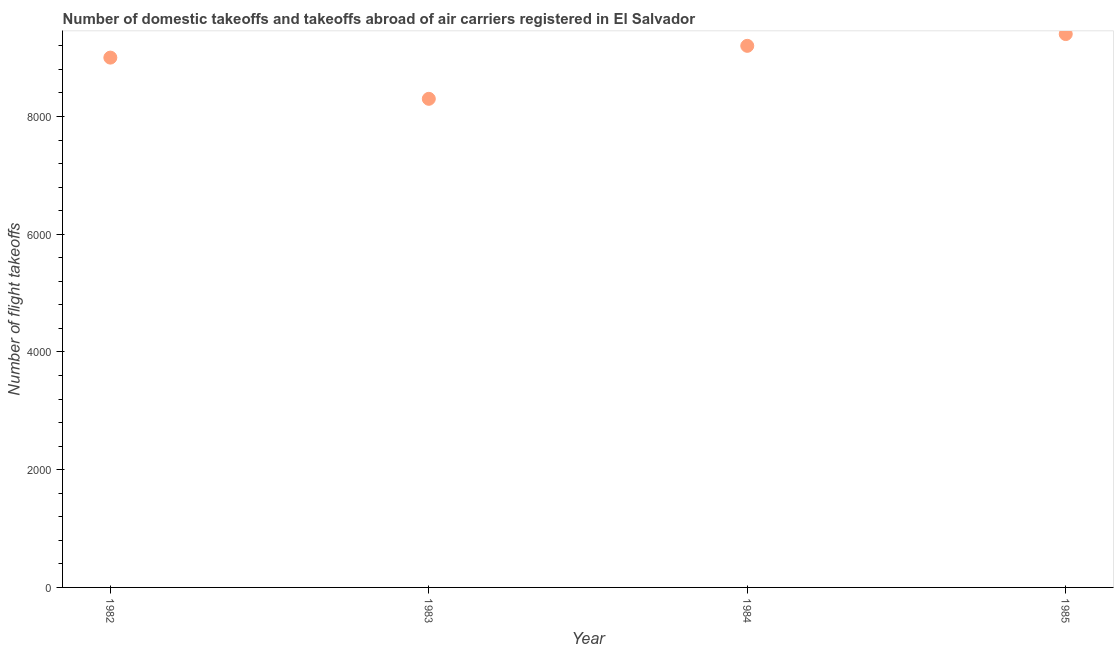What is the number of flight takeoffs in 1983?
Make the answer very short. 8300. Across all years, what is the maximum number of flight takeoffs?
Make the answer very short. 9400. Across all years, what is the minimum number of flight takeoffs?
Offer a very short reply. 8300. In which year was the number of flight takeoffs maximum?
Give a very brief answer. 1985. What is the sum of the number of flight takeoffs?
Offer a very short reply. 3.59e+04. What is the difference between the number of flight takeoffs in 1982 and 1983?
Offer a terse response. 700. What is the average number of flight takeoffs per year?
Keep it short and to the point. 8975. What is the median number of flight takeoffs?
Offer a very short reply. 9100. In how many years, is the number of flight takeoffs greater than 400 ?
Provide a succinct answer. 4. What is the ratio of the number of flight takeoffs in 1984 to that in 1985?
Keep it short and to the point. 0.98. What is the difference between the highest and the lowest number of flight takeoffs?
Your response must be concise. 1100. In how many years, is the number of flight takeoffs greater than the average number of flight takeoffs taken over all years?
Your response must be concise. 3. Does the number of flight takeoffs monotonically increase over the years?
Keep it short and to the point. No. How many dotlines are there?
Offer a very short reply. 1. How many years are there in the graph?
Provide a succinct answer. 4. Does the graph contain any zero values?
Offer a terse response. No. What is the title of the graph?
Your response must be concise. Number of domestic takeoffs and takeoffs abroad of air carriers registered in El Salvador. What is the label or title of the Y-axis?
Ensure brevity in your answer.  Number of flight takeoffs. What is the Number of flight takeoffs in 1982?
Your answer should be very brief. 9000. What is the Number of flight takeoffs in 1983?
Make the answer very short. 8300. What is the Number of flight takeoffs in 1984?
Provide a succinct answer. 9200. What is the Number of flight takeoffs in 1985?
Ensure brevity in your answer.  9400. What is the difference between the Number of flight takeoffs in 1982 and 1983?
Keep it short and to the point. 700. What is the difference between the Number of flight takeoffs in 1982 and 1984?
Provide a short and direct response. -200. What is the difference between the Number of flight takeoffs in 1982 and 1985?
Ensure brevity in your answer.  -400. What is the difference between the Number of flight takeoffs in 1983 and 1984?
Offer a terse response. -900. What is the difference between the Number of flight takeoffs in 1983 and 1985?
Your answer should be very brief. -1100. What is the difference between the Number of flight takeoffs in 1984 and 1985?
Keep it short and to the point. -200. What is the ratio of the Number of flight takeoffs in 1982 to that in 1983?
Your response must be concise. 1.08. What is the ratio of the Number of flight takeoffs in 1983 to that in 1984?
Provide a short and direct response. 0.9. What is the ratio of the Number of flight takeoffs in 1983 to that in 1985?
Your answer should be very brief. 0.88. What is the ratio of the Number of flight takeoffs in 1984 to that in 1985?
Offer a terse response. 0.98. 